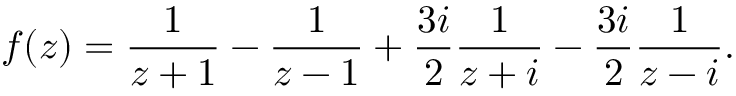Convert formula to latex. <formula><loc_0><loc_0><loc_500><loc_500>f ( z ) = { \frac { 1 } { z + 1 } } - { \frac { 1 } { z - 1 } } + { \frac { 3 i } { 2 } } { \frac { 1 } { z + i } } - { \frac { 3 i } { 2 } } { \frac { 1 } { z - i } } .</formula> 